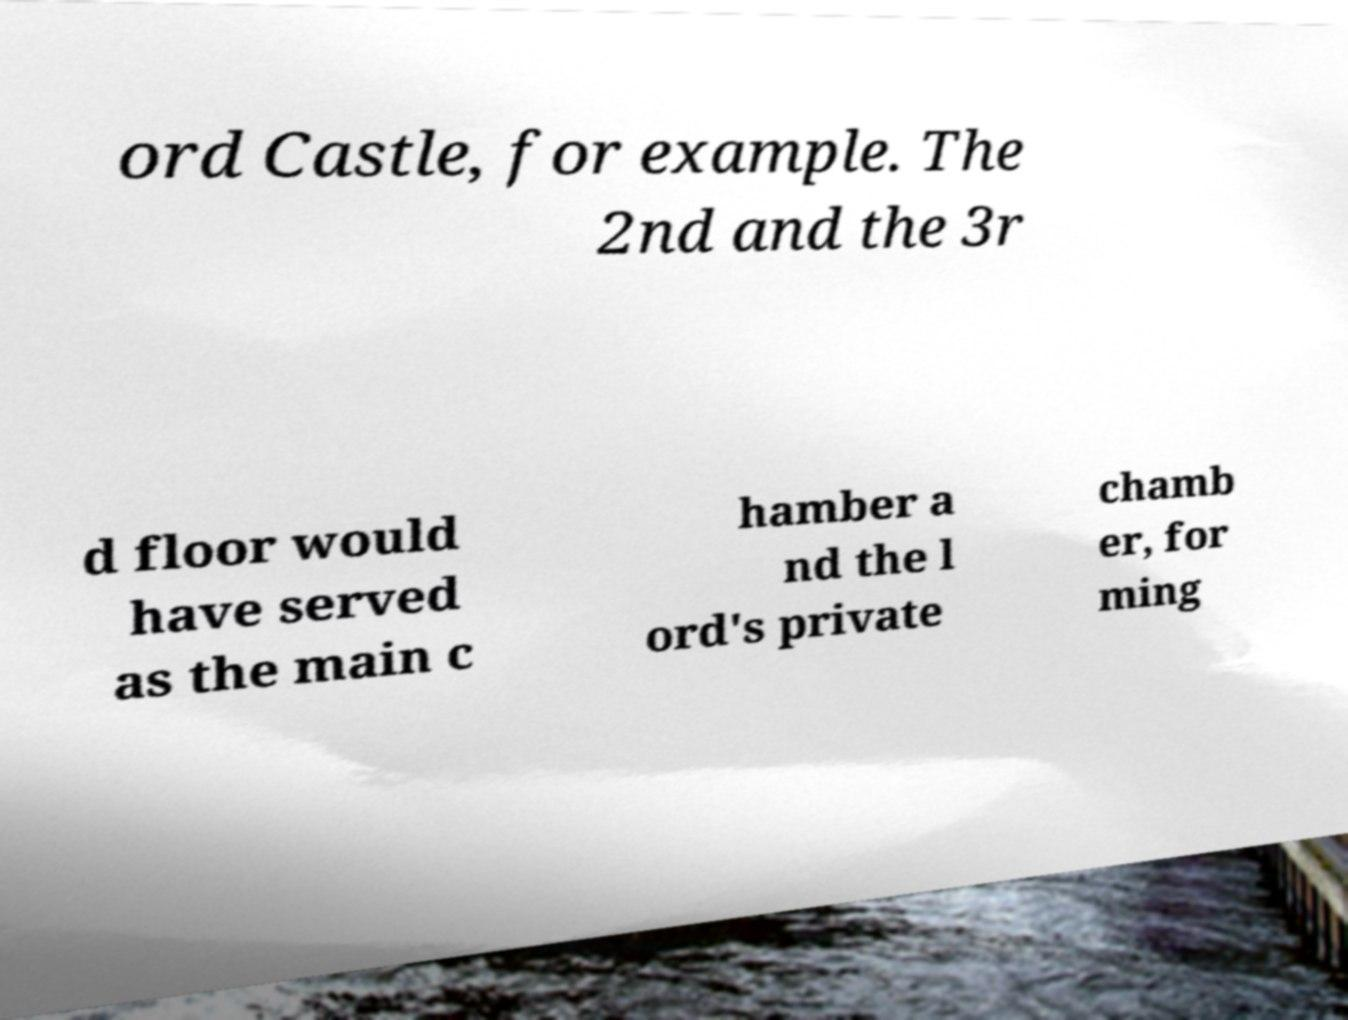There's text embedded in this image that I need extracted. Can you transcribe it verbatim? ord Castle, for example. The 2nd and the 3r d floor would have served as the main c hamber a nd the l ord's private chamb er, for ming 